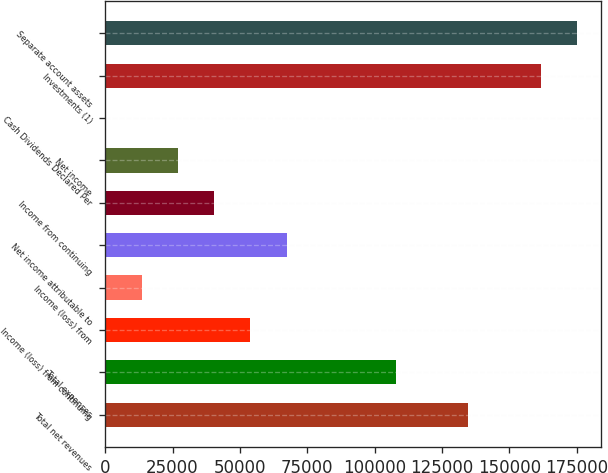Convert chart. <chart><loc_0><loc_0><loc_500><loc_500><bar_chart><fcel>Total net revenues<fcel>Total expenses<fcel>Income (loss) from continuing<fcel>Income (loss) from<fcel>Net income attributable to<fcel>Income from continuing<fcel>Net income<fcel>Cash Dividends Declared Per<fcel>Investments (1)<fcel>Separate account assets<nl><fcel>134729<fcel>107783<fcel>53892.3<fcel>13473.9<fcel>67365.1<fcel>40419.5<fcel>26946.7<fcel>1.15<fcel>161675<fcel>175147<nl></chart> 